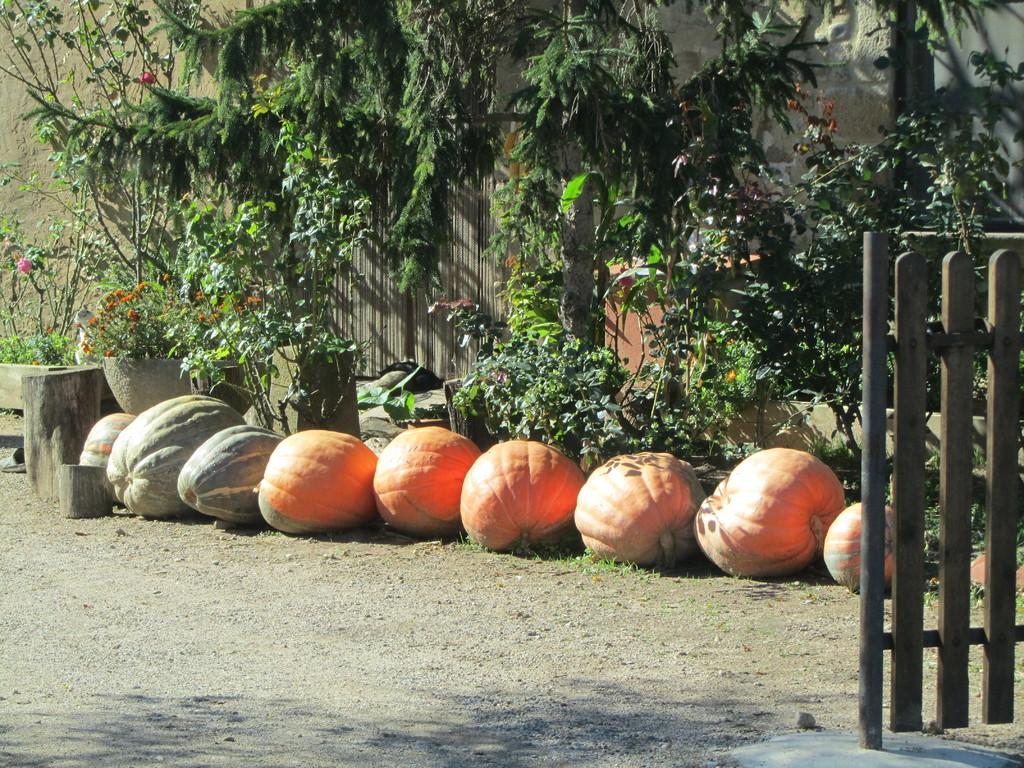What type of vegetable is present on the ground in the image? There are pumpkins on the ground in the image. What can be seen in the distance in the image? There are trees visible in the background of the image. What type of plants are in pots in the image? There are flowers on plants kept in pots in the image. What type of gate is present in the image? There is a wooden gate in the image. How many children are playing with the oil in the image? There are no children or oil present in the image. What type of humor is depicted in the image? There is no humor depicted in the image; it features pumpkins, trees, flowers, and a wooden gate. 